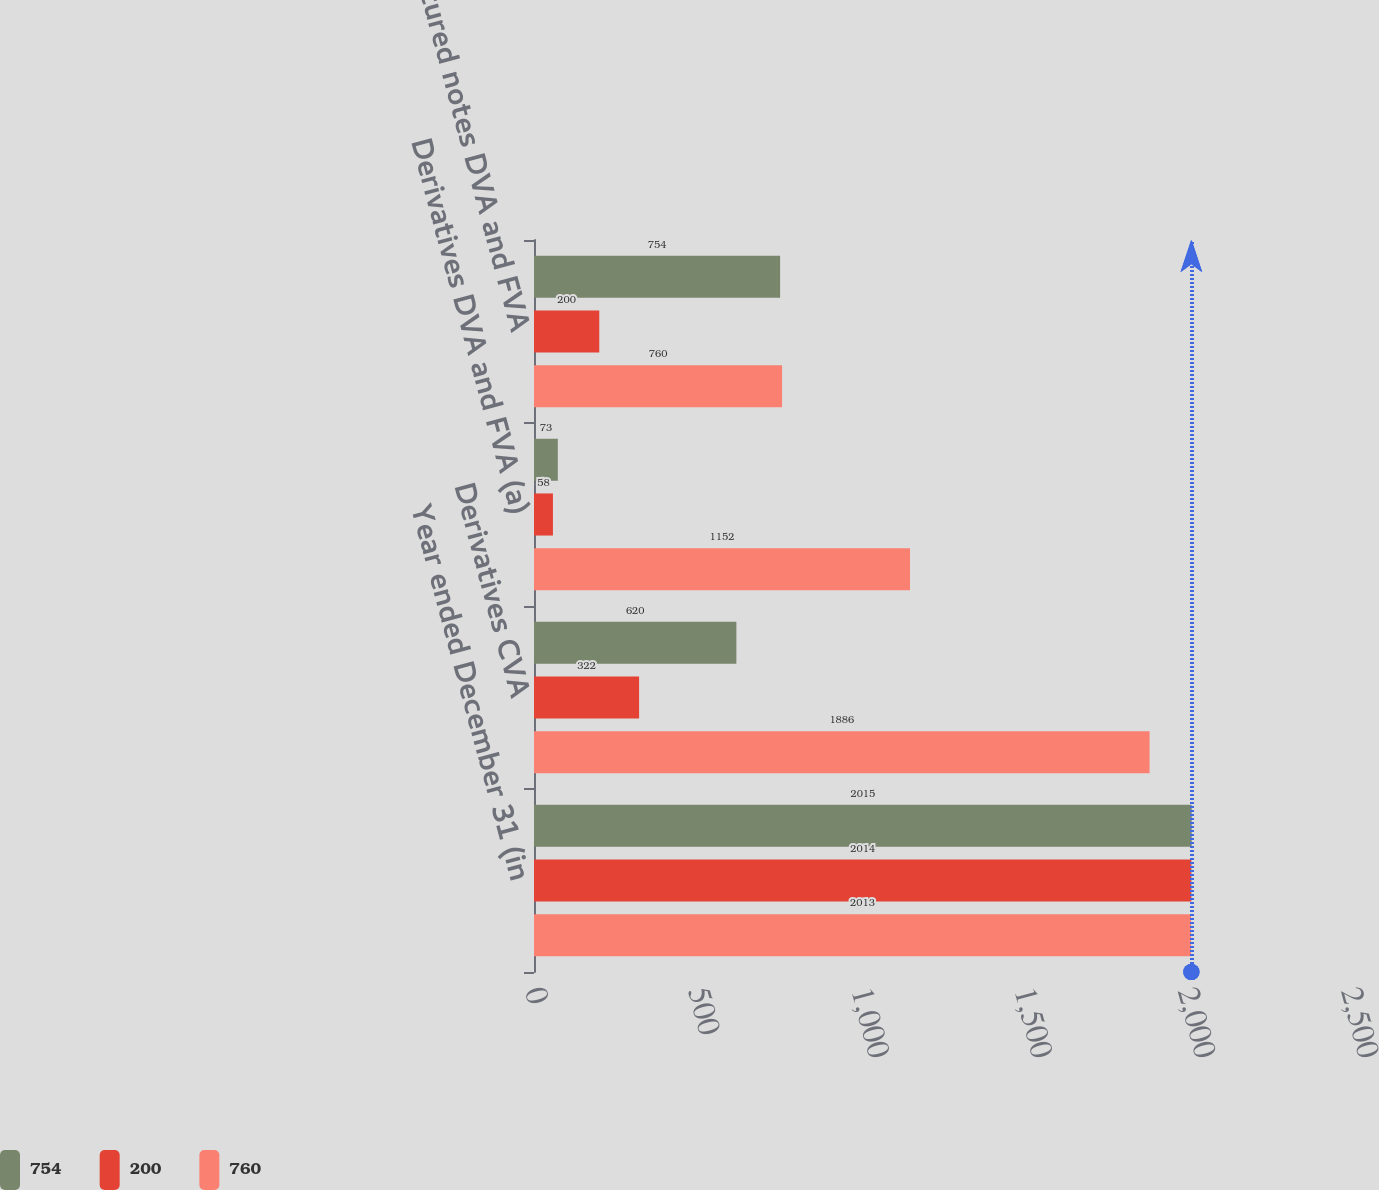Convert chart. <chart><loc_0><loc_0><loc_500><loc_500><stacked_bar_chart><ecel><fcel>Year ended December 31 (in<fcel>Derivatives CVA<fcel>Derivatives DVA and FVA (a)<fcel>Structured notes DVA and FVA<nl><fcel>754<fcel>2015<fcel>620<fcel>73<fcel>754<nl><fcel>200<fcel>2014<fcel>322<fcel>58<fcel>200<nl><fcel>760<fcel>2013<fcel>1886<fcel>1152<fcel>760<nl></chart> 